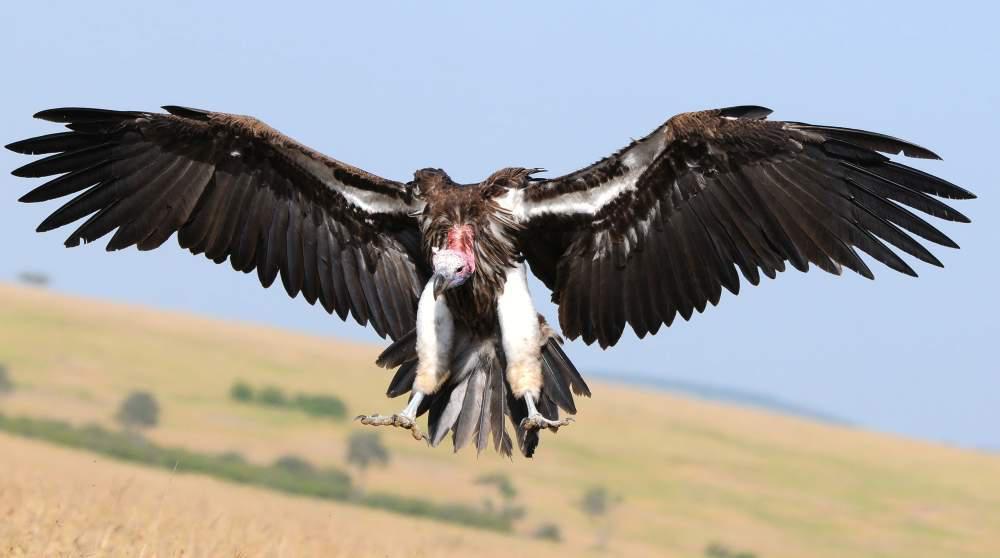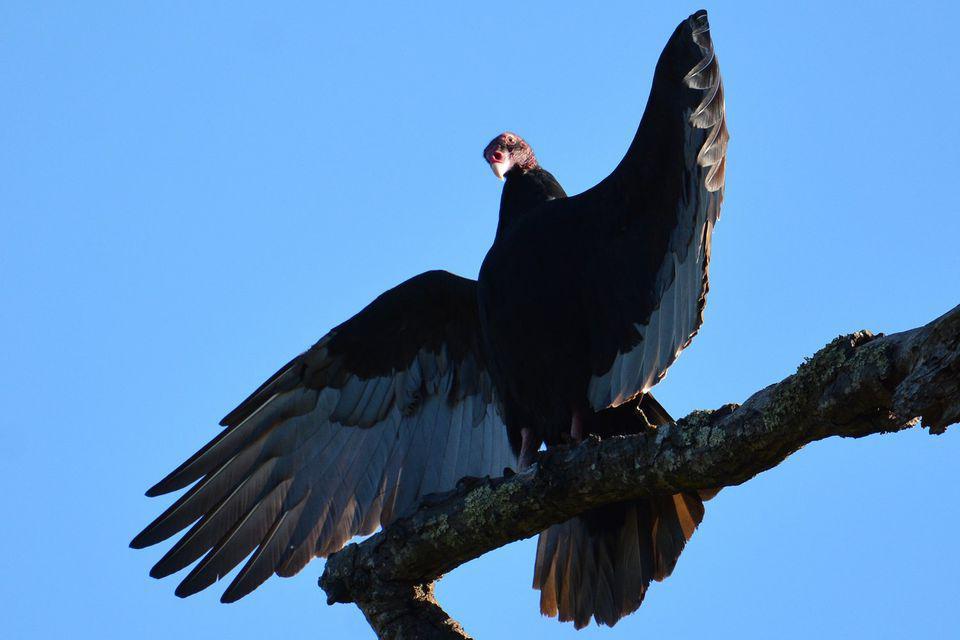The first image is the image on the left, the second image is the image on the right. Examine the images to the left and right. Is the description "One image contains more than four vultures on a tree that is at least mostly bare, and the other contains a single vulture." accurate? Answer yes or no. No. The first image is the image on the left, the second image is the image on the right. Given the left and right images, does the statement "Each image includes a vulture with outspread wings, and one image contains a single vulture that is in mid-air." hold true? Answer yes or no. Yes. 